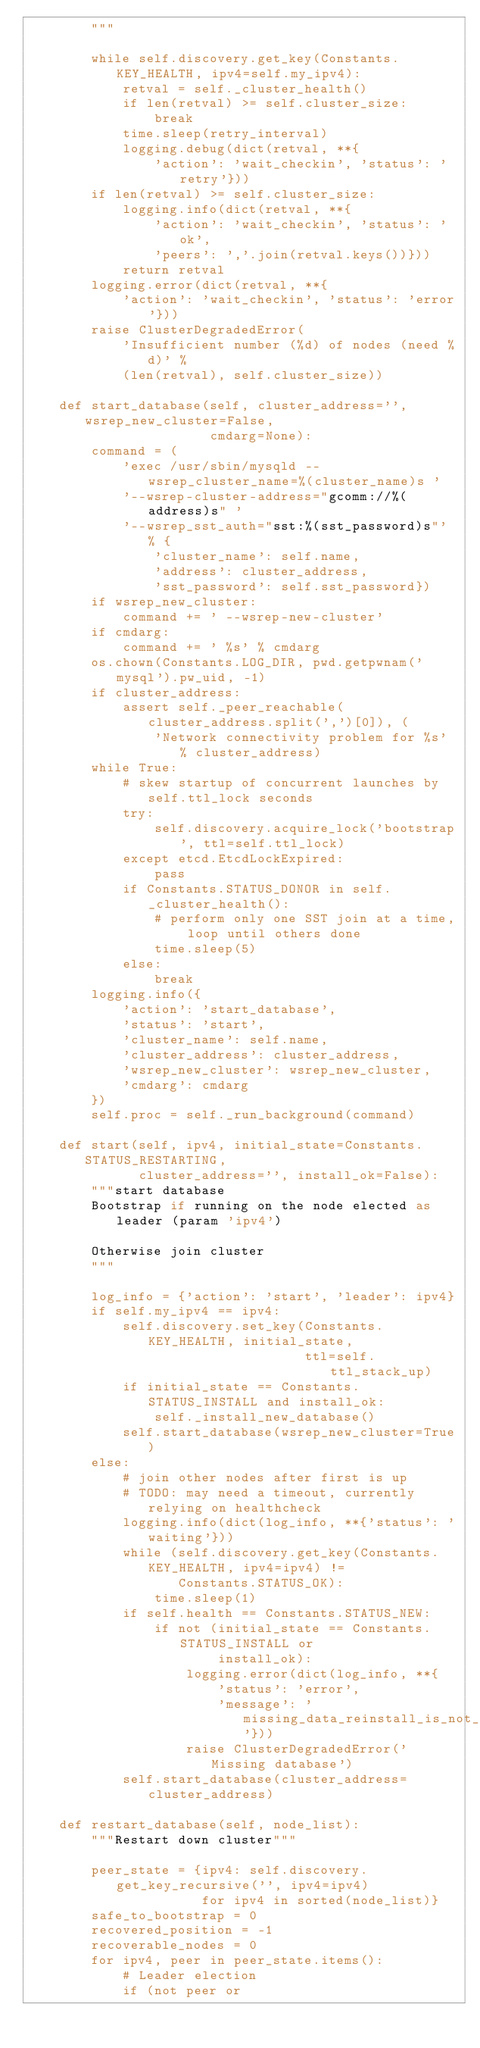<code> <loc_0><loc_0><loc_500><loc_500><_Python_>        """

        while self.discovery.get_key(Constants.KEY_HEALTH, ipv4=self.my_ipv4):
            retval = self._cluster_health()
            if len(retval) >= self.cluster_size:
                break
            time.sleep(retry_interval)
            logging.debug(dict(retval, **{
                'action': 'wait_checkin', 'status': 'retry'}))
        if len(retval) >= self.cluster_size:
            logging.info(dict(retval, **{
                'action': 'wait_checkin', 'status': 'ok',
                'peers': ','.join(retval.keys())}))
            return retval
        logging.error(dict(retval, **{
            'action': 'wait_checkin', 'status': 'error'}))
        raise ClusterDegradedError(
            'Insufficient number (%d) of nodes (need %d)' %
            (len(retval), self.cluster_size))

    def start_database(self, cluster_address='', wsrep_new_cluster=False,
                       cmdarg=None):
        command = (
            'exec /usr/sbin/mysqld --wsrep_cluster_name=%(cluster_name)s '
            '--wsrep-cluster-address="gcomm://%(address)s" '
            '--wsrep_sst_auth="sst:%(sst_password)s"' % {
                'cluster_name': self.name,
                'address': cluster_address,
                'sst_password': self.sst_password})
        if wsrep_new_cluster:
            command += ' --wsrep-new-cluster'
        if cmdarg:
            command += ' %s' % cmdarg
        os.chown(Constants.LOG_DIR, pwd.getpwnam('mysql').pw_uid, -1)
        if cluster_address:
            assert self._peer_reachable(cluster_address.split(',')[0]), (
                'Network connectivity problem for %s' % cluster_address)
        while True:
            # skew startup of concurrent launches by self.ttl_lock seconds
            try:
                self.discovery.acquire_lock('bootstrap', ttl=self.ttl_lock)
            except etcd.EtcdLockExpired:
                pass
            if Constants.STATUS_DONOR in self._cluster_health():
                # perform only one SST join at a time, loop until others done
                time.sleep(5)
            else:
                break
        logging.info({
            'action': 'start_database',
            'status': 'start',
            'cluster_name': self.name,
            'cluster_address': cluster_address,
            'wsrep_new_cluster': wsrep_new_cluster,
            'cmdarg': cmdarg
        })
        self.proc = self._run_background(command)

    def start(self, ipv4, initial_state=Constants.STATUS_RESTARTING,
              cluster_address='', install_ok=False):
        """start database
        Bootstrap if running on the node elected as leader (param 'ipv4')

        Otherwise join cluster
        """

        log_info = {'action': 'start', 'leader': ipv4}
        if self.my_ipv4 == ipv4:
            self.discovery.set_key(Constants.KEY_HEALTH, initial_state,
                                   ttl=self.ttl_stack_up)
            if initial_state == Constants.STATUS_INSTALL and install_ok:
                self._install_new_database()
            self.start_database(wsrep_new_cluster=True)
        else:
            # join other nodes after first is up
            # TODO: may need a timeout, currently relying on healthcheck
            logging.info(dict(log_info, **{'status': 'waiting'}))
            while (self.discovery.get_key(Constants.KEY_HEALTH, ipv4=ipv4) !=
                   Constants.STATUS_OK):
                time.sleep(1)
            if self.health == Constants.STATUS_NEW:
                if not (initial_state == Constants.STATUS_INSTALL or
                        install_ok):
                    logging.error(dict(log_info, **{
                        'status': 'error',
                        'message': 'missing_data_reinstall_is_not_ok'}))
                    raise ClusterDegradedError('Missing database')
            self.start_database(cluster_address=cluster_address)

    def restart_database(self, node_list):
        """Restart down cluster"""

        peer_state = {ipv4: self.discovery.get_key_recursive('', ipv4=ipv4)
                      for ipv4 in sorted(node_list)}
        safe_to_bootstrap = 0
        recovered_position = -1
        recoverable_nodes = 0
        for ipv4, peer in peer_state.items():
            # Leader election
            if (not peer or</code> 